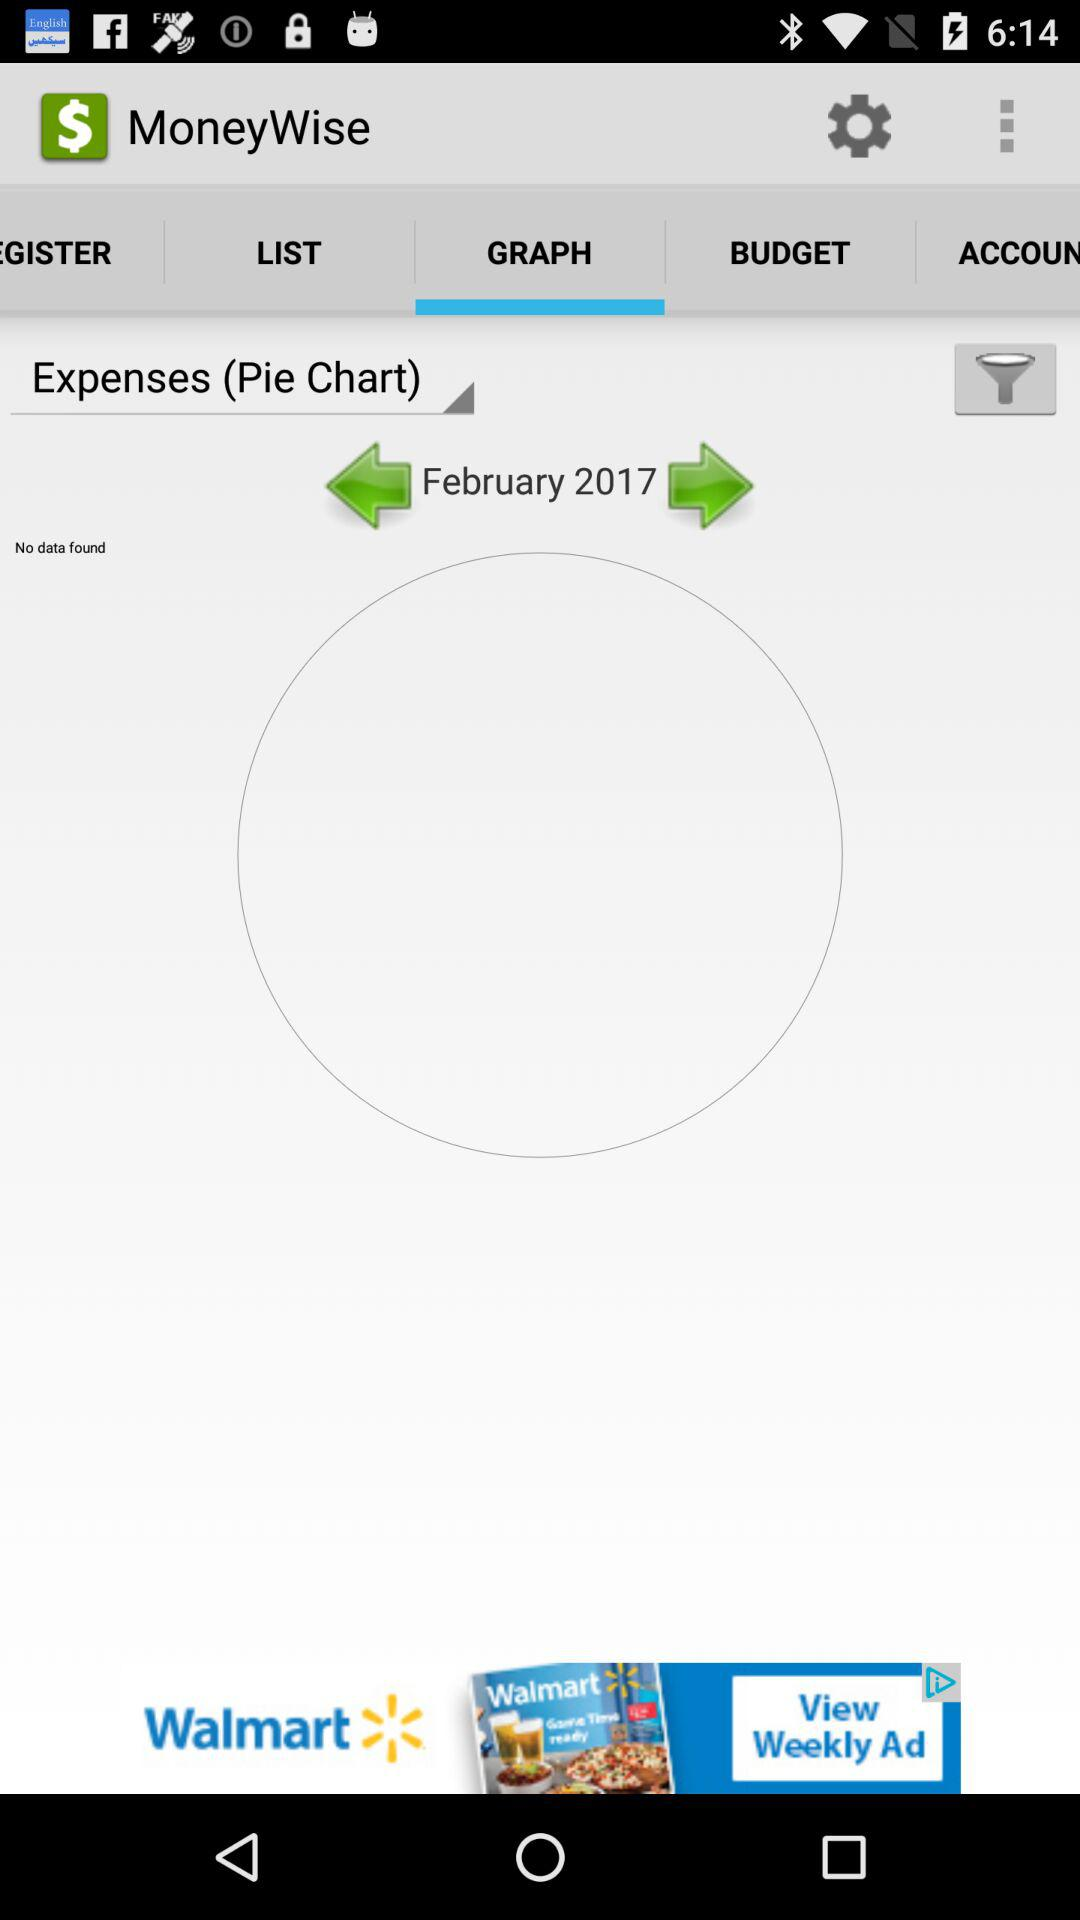Which tab has been selected? The selected tab is "GRAPH". 